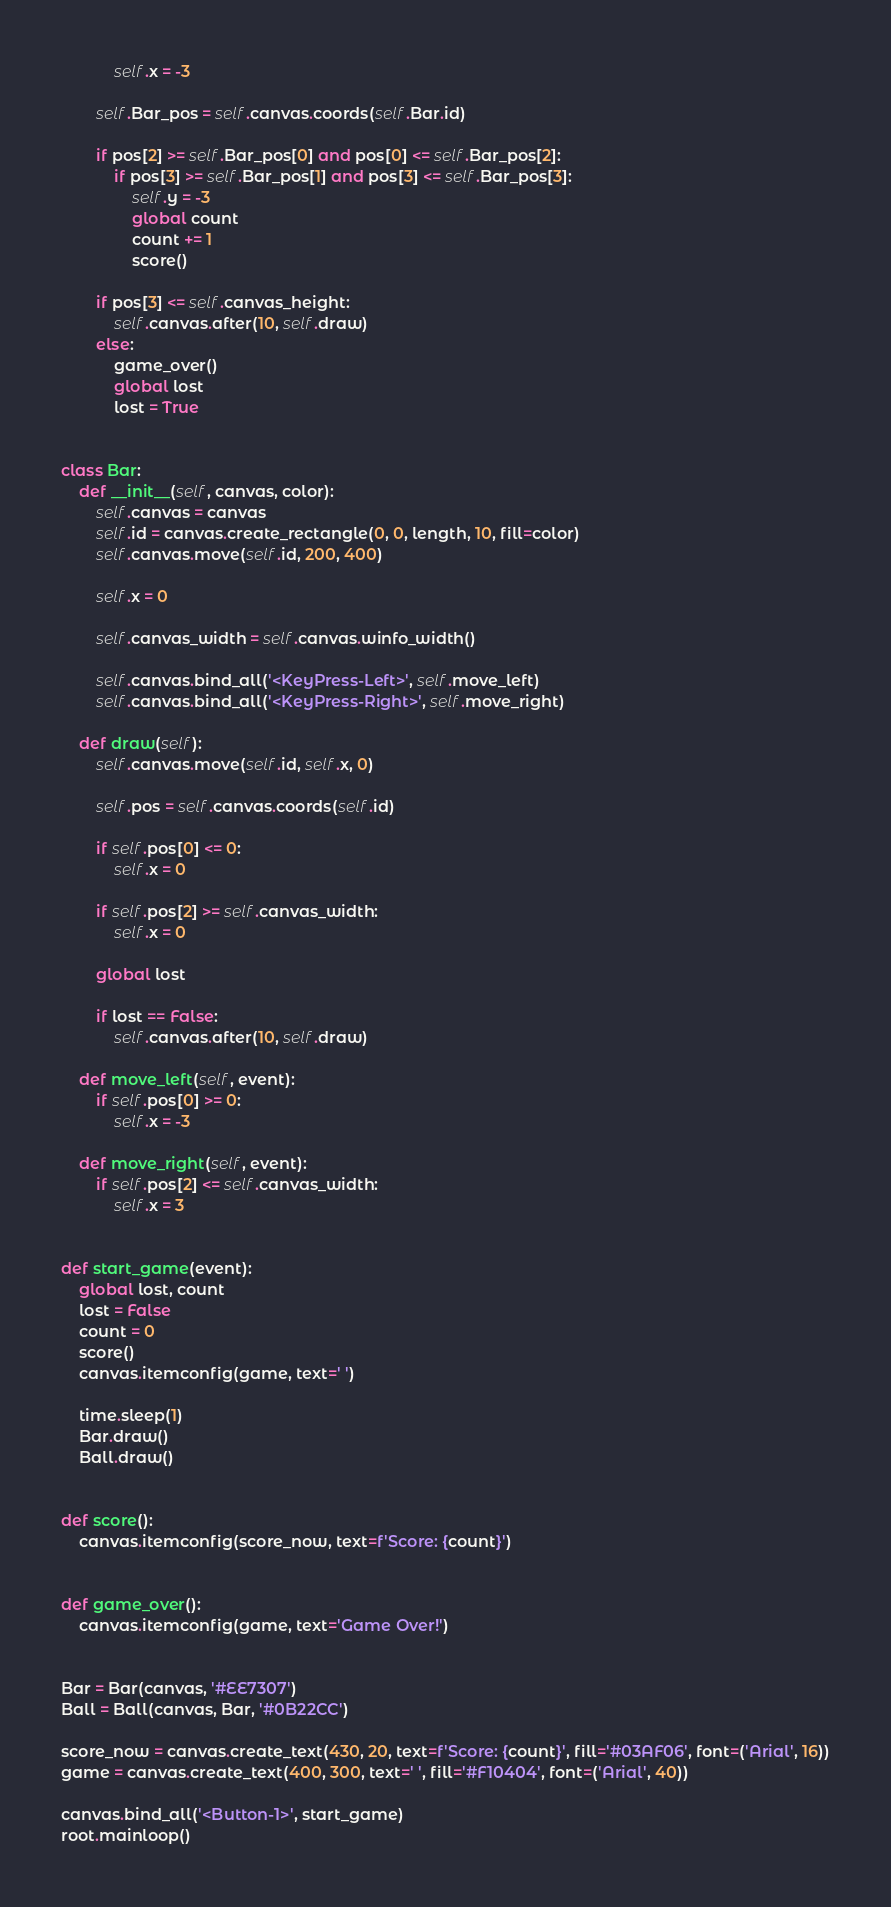<code> <loc_0><loc_0><loc_500><loc_500><_Python_>            self.x = -3

        self.Bar_pos = self.canvas.coords(self.Bar.id)

        if pos[2] >= self.Bar_pos[0] and pos[0] <= self.Bar_pos[2]:
            if pos[3] >= self.Bar_pos[1] and pos[3] <= self.Bar_pos[3]:
                self.y = -3
                global count
                count += 1
                score()

        if pos[3] <= self.canvas_height:
            self.canvas.after(10, self.draw)
        else:
            game_over()
            global lost
            lost = True


class Bar:
    def __init__(self, canvas, color):
        self.canvas = canvas
        self.id = canvas.create_rectangle(0, 0, length, 10, fill=color)
        self.canvas.move(self.id, 200, 400)

        self.x = 0

        self.canvas_width = self.canvas.winfo_width()

        self.canvas.bind_all('<KeyPress-Left>', self.move_left)
        self.canvas.bind_all('<KeyPress-Right>', self.move_right)

    def draw(self):
        self.canvas.move(self.id, self.x, 0)

        self.pos = self.canvas.coords(self.id)

        if self.pos[0] <= 0:
            self.x = 0

        if self.pos[2] >= self.canvas_width:
            self.x = 0

        global lost

        if lost == False:
            self.canvas.after(10, self.draw)

    def move_left(self, event):
        if self.pos[0] >= 0:
            self.x = -3

    def move_right(self, event):
        if self.pos[2] <= self.canvas_width:
            self.x = 3


def start_game(event):
    global lost, count
    lost = False
    count = 0
    score()
    canvas.itemconfig(game, text=' ')

    time.sleep(1)
    Bar.draw()
    Ball.draw()


def score():
    canvas.itemconfig(score_now, text=f'Score: {count}')


def game_over():
    canvas.itemconfig(game, text='Game Over!')


Bar = Bar(canvas, '#EE7307')
Ball = Ball(canvas, Bar, '#0B22CC')

score_now = canvas.create_text(430, 20, text=f'Score: {count}', fill='#03AF06', font=('Arial', 16))
game = canvas.create_text(400, 300, text=' ', fill='#F10404', font=('Arial', 40))

canvas.bind_all('<Button-1>', start_game)
root.mainloop()
</code> 